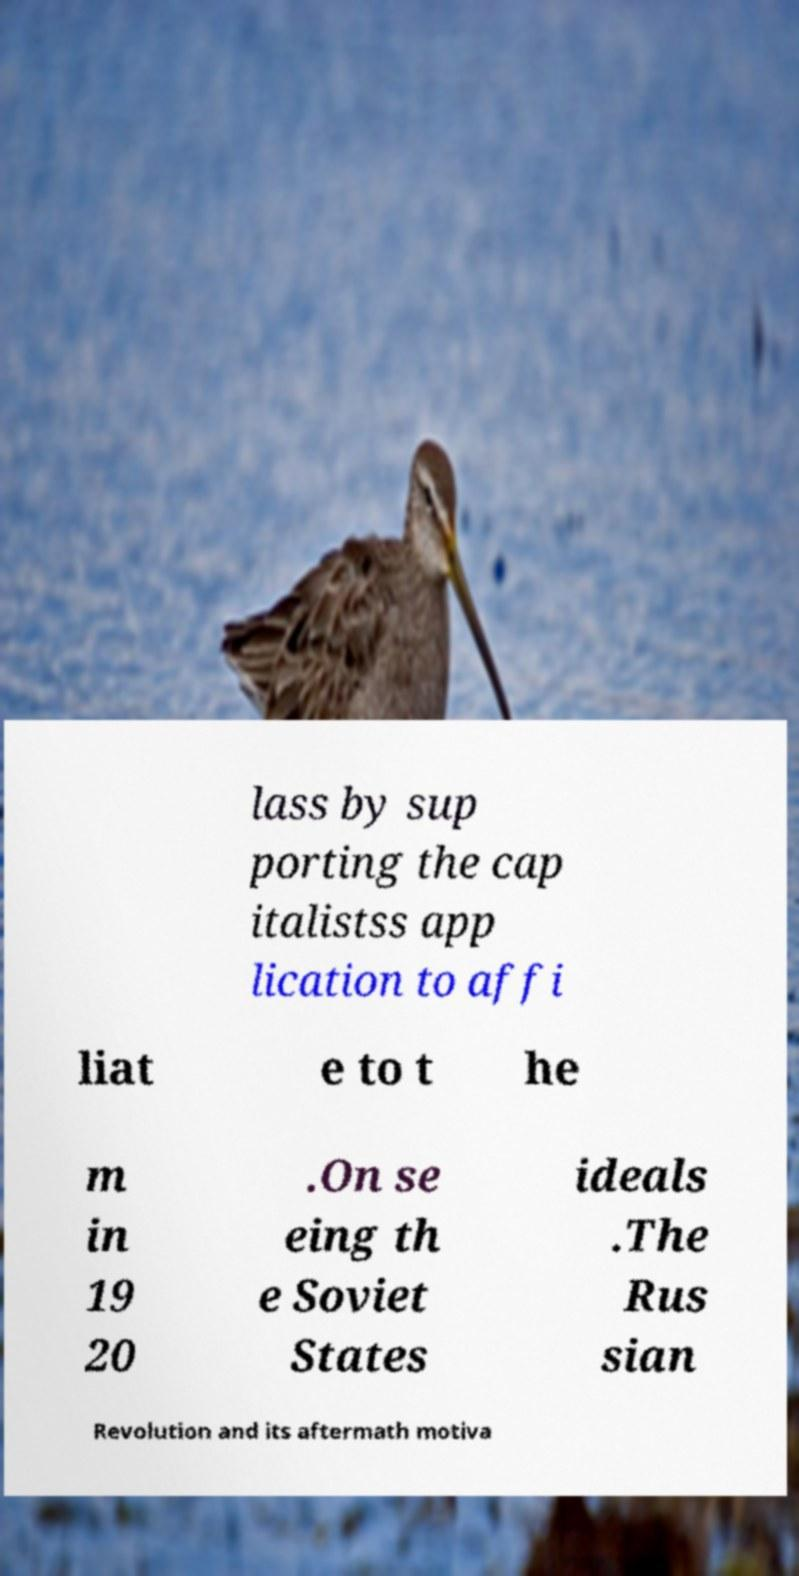I need the written content from this picture converted into text. Can you do that? lass by sup porting the cap italistss app lication to affi liat e to t he m in 19 20 .On se eing th e Soviet States ideals .The Rus sian Revolution and its aftermath motiva 